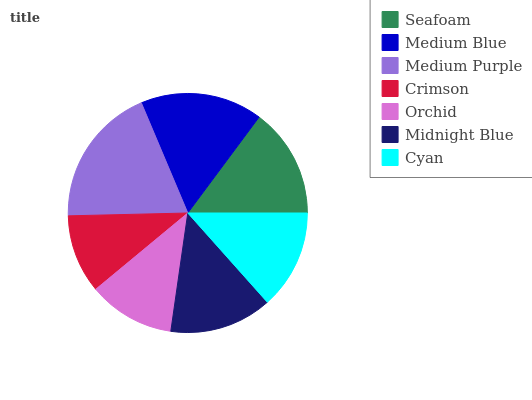Is Crimson the minimum?
Answer yes or no. Yes. Is Medium Purple the maximum?
Answer yes or no. Yes. Is Medium Blue the minimum?
Answer yes or no. No. Is Medium Blue the maximum?
Answer yes or no. No. Is Medium Blue greater than Seafoam?
Answer yes or no. Yes. Is Seafoam less than Medium Blue?
Answer yes or no. Yes. Is Seafoam greater than Medium Blue?
Answer yes or no. No. Is Medium Blue less than Seafoam?
Answer yes or no. No. Is Midnight Blue the high median?
Answer yes or no. Yes. Is Midnight Blue the low median?
Answer yes or no. Yes. Is Crimson the high median?
Answer yes or no. No. Is Orchid the low median?
Answer yes or no. No. 